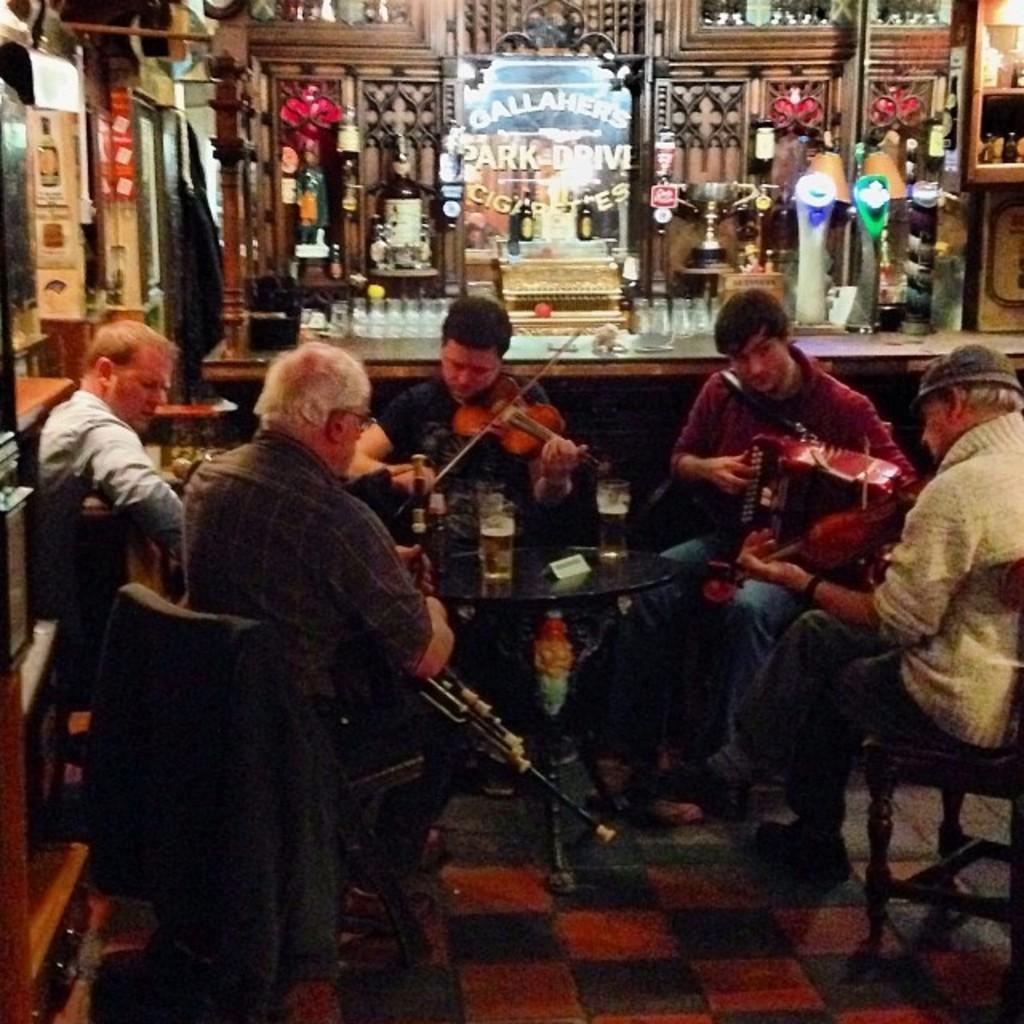Can you describe this image briefly? In the center of the image there are five people sitting on chairs. There is a table on which there is a glass. The person sitting in center is wearing a blue color t-shirt and he is playing a violin. Beside him there is a person sitting on a chair he is wearing a red color shirt. At the background of the image there is a bar counter. 